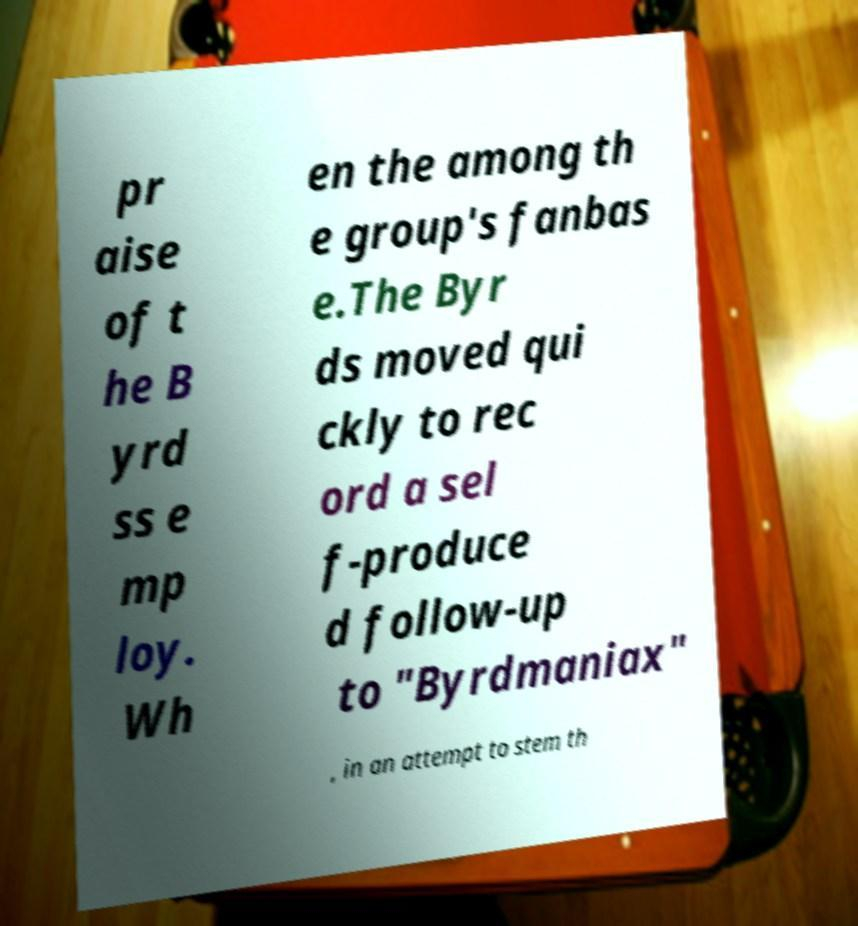Can you read and provide the text displayed in the image?This photo seems to have some interesting text. Can you extract and type it out for me? pr aise of t he B yrd ss e mp loy. Wh en the among th e group's fanbas e.The Byr ds moved qui ckly to rec ord a sel f-produce d follow-up to "Byrdmaniax" , in an attempt to stem th 